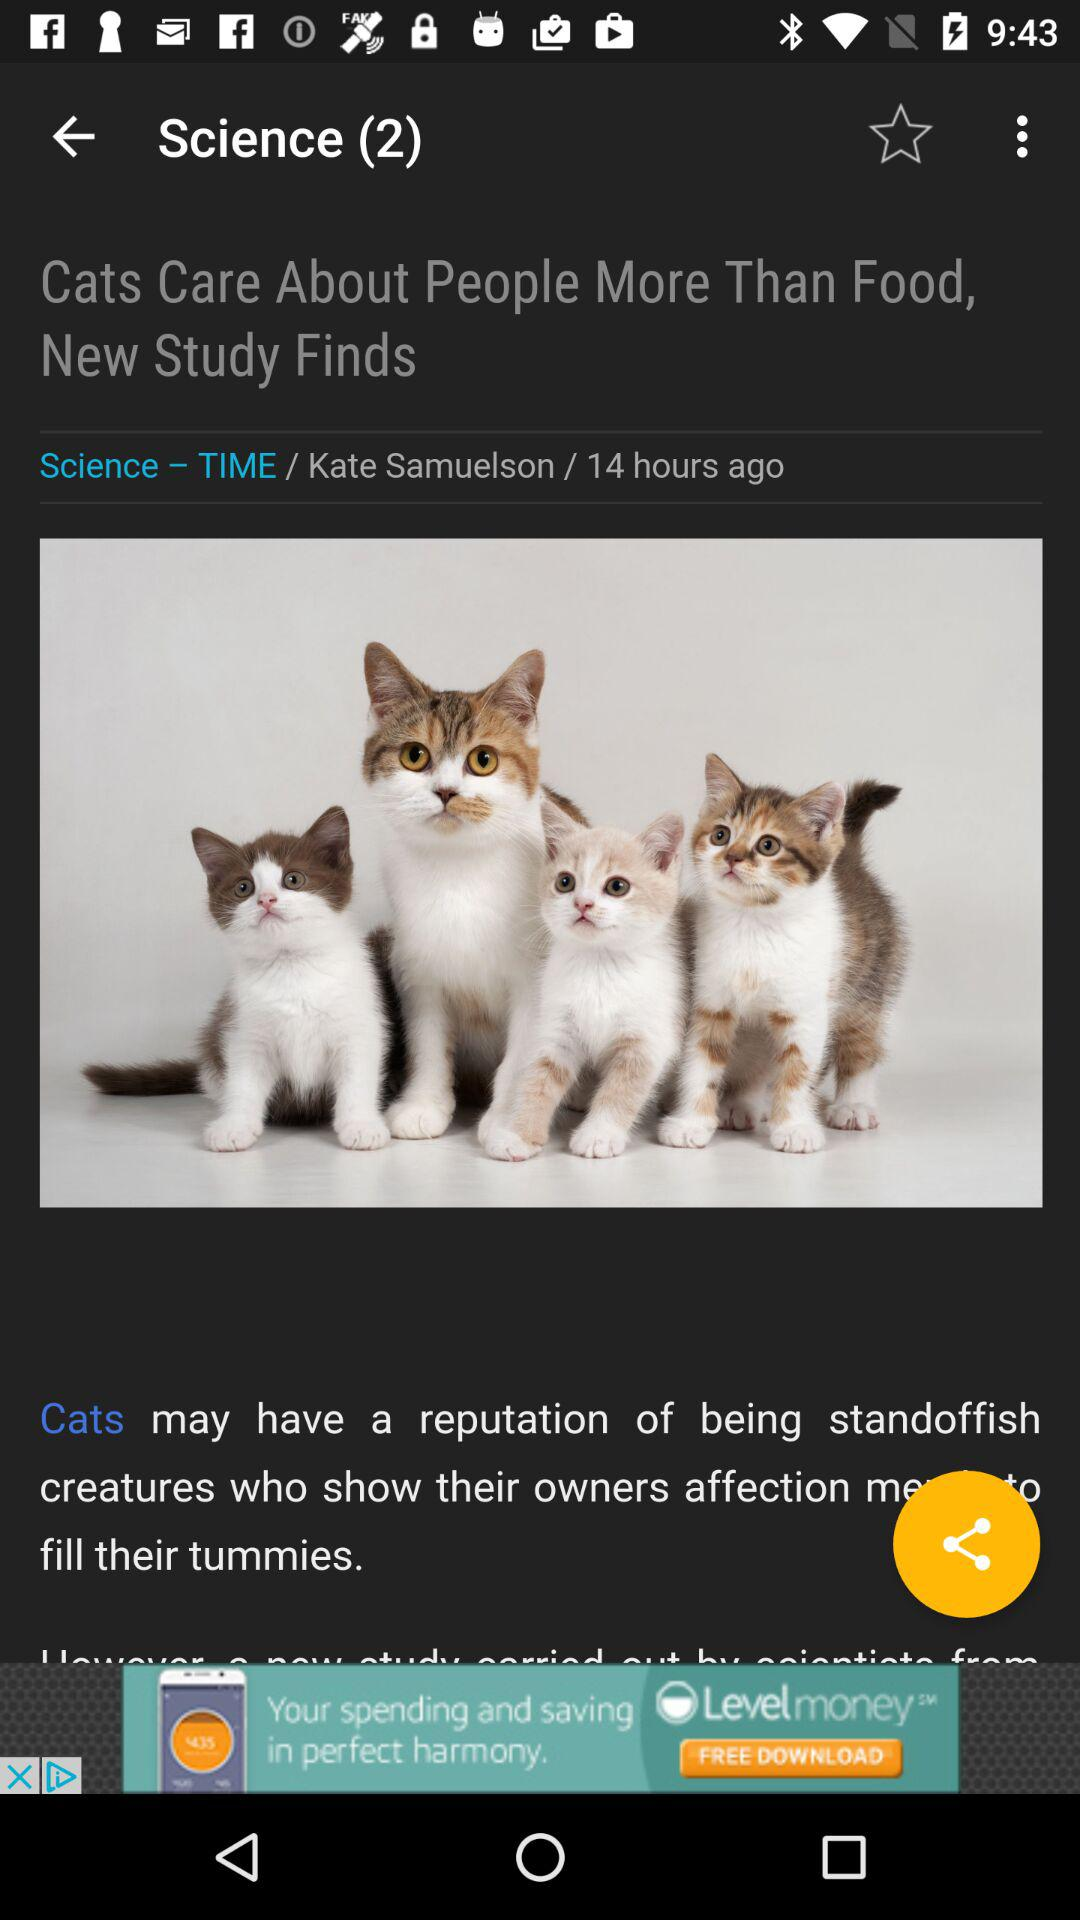When was the content posted? The content was posted 14 hours ago. 